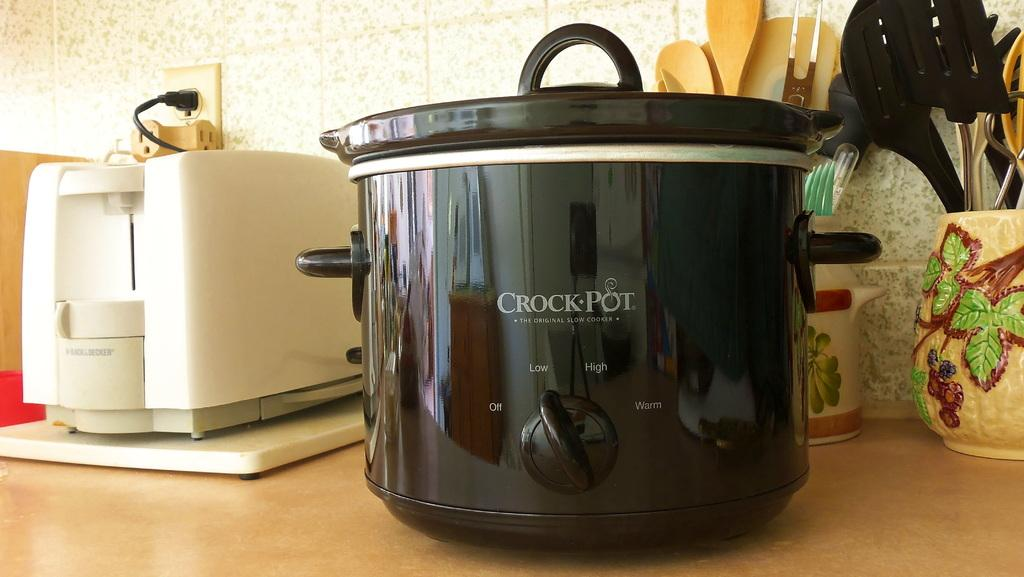<image>
Write a terse but informative summary of the picture. A black Crock Pot sits on a kitchen counter next to a toaster. 